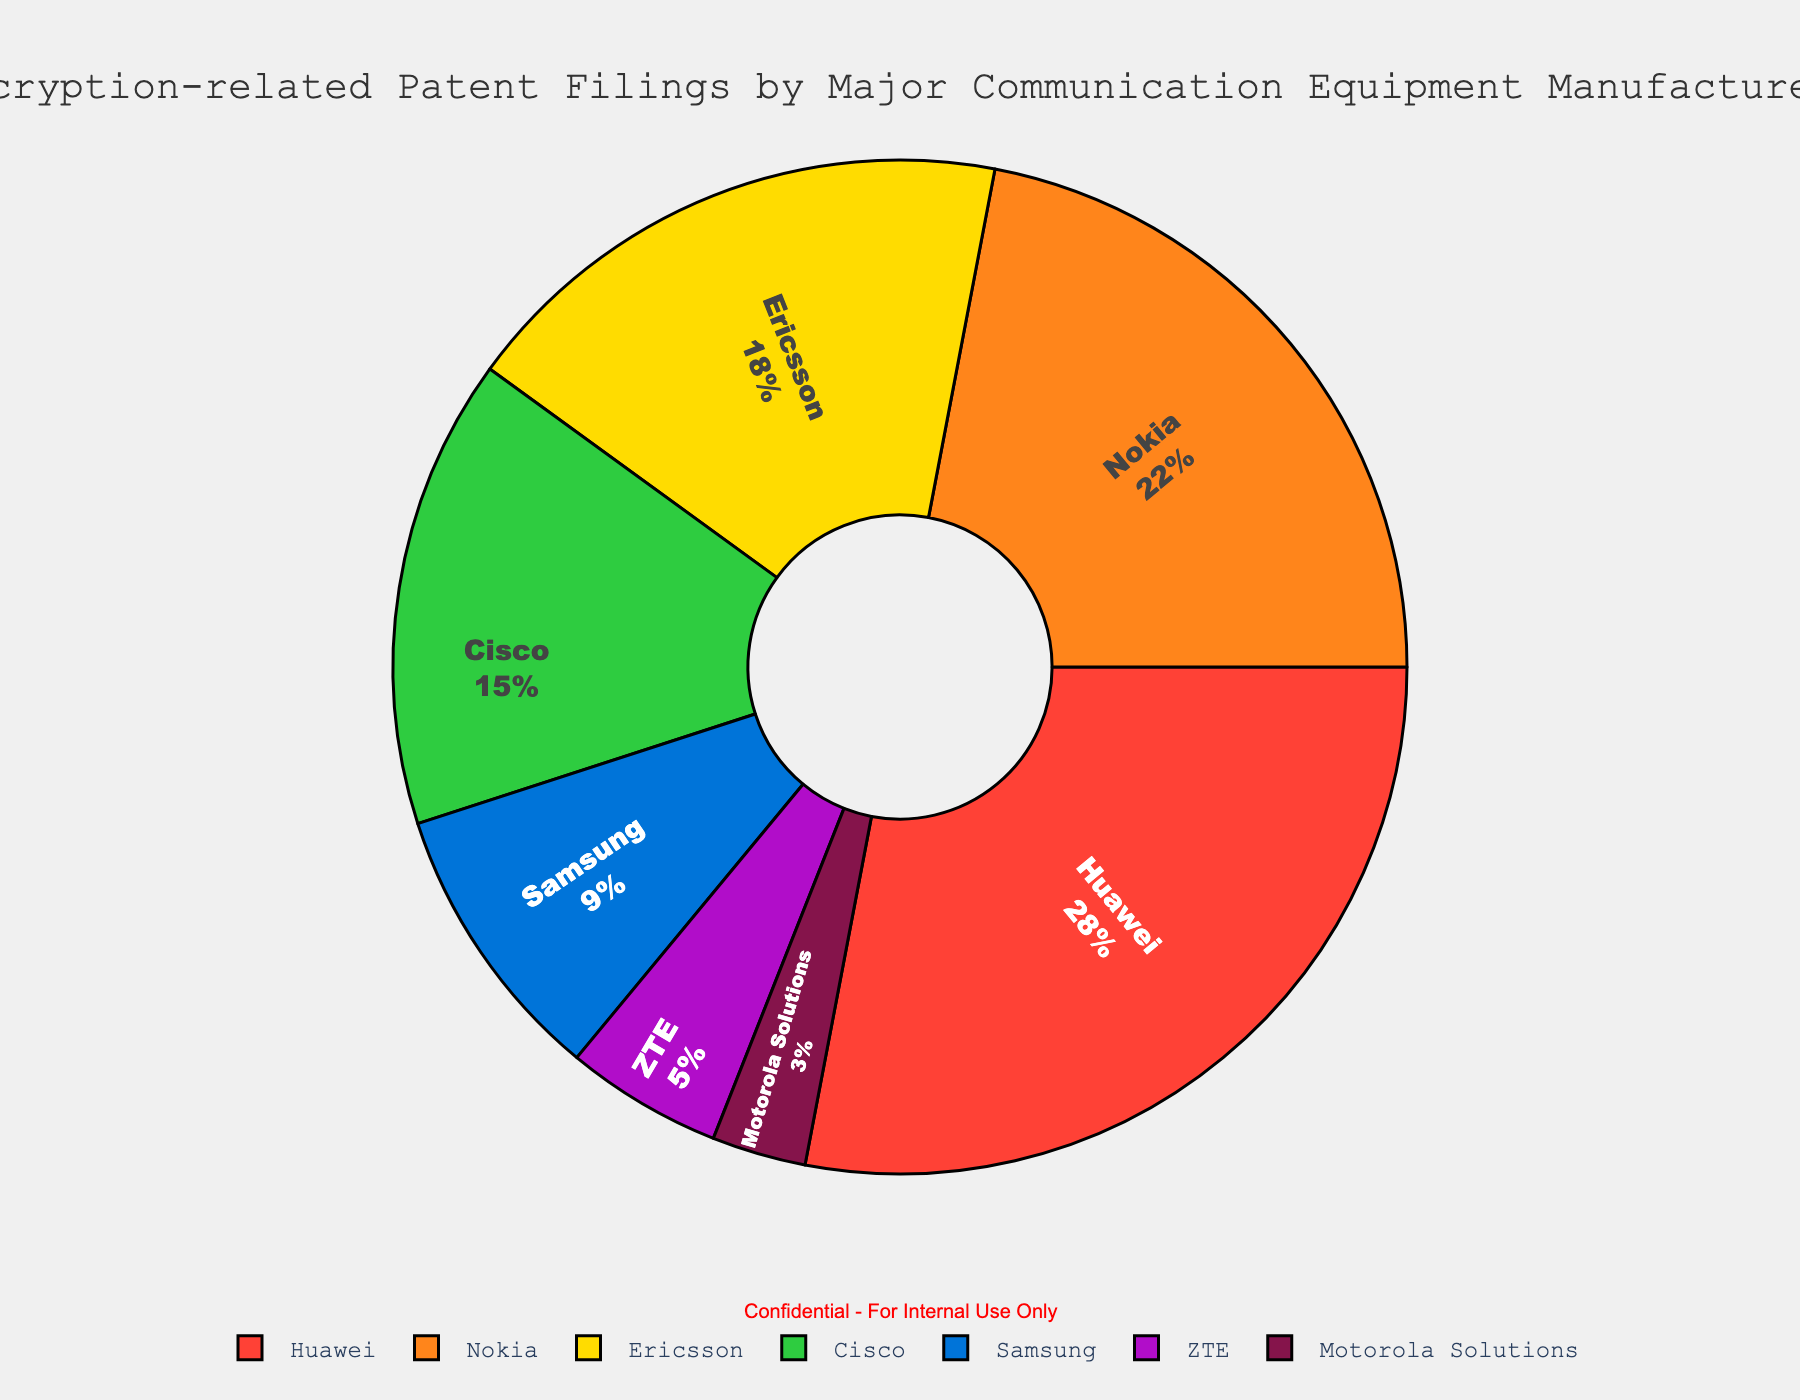What percentage of encryption-related patent filings do Huawei and Nokia have together? Add Huawei's percentage (28%) and Nokia's percentage (22%). 28 + 22 = 50
Answer: 50% What is the difference in encryption-related patent filings between Ericsson and Cisco? Subtract Cisco's percentage (15%) from Ericsson's percentage (18%). 18 - 15 = 3
Answer: 3% Which company has the second-highest percentage of encryption-related patent filings? The company with the second-highest percentage is Nokia with 22%, as Huawei has the highest at 28%.
Answer: Nokia Which companies have less than 10% of the encryption-related patent filings? From the data: Samsung (9%), ZTE (5%), Motorola Solutions (3%) are all less than 10%.
Answer: Samsung, ZTE, Motorola Solutions If you combine the encryption-related patent filings of Samsung, ZTE, and Motorola Solutions, what percentage of the total do they represent? Add the percentages of Samsung (9%), ZTE (5%), and Motorola Solutions (3%). 9 + 5 + 3 = 17
Answer: 17% Which company occupies the segment with the color green? The green segment belongs to Samsung in the pie chart.
Answer: Samsung How does the percentage of encryption-related patent filings for Cisco compare to that of ZTE? Cisco has 15%, while ZTE has 5%. 15% is greater than 5%.
Answer: Cisco's percentage is greater What is the combined percentage of encryption-related patent filings by companies other than Huawei and Nokia? Add the percentages of Ericsson (18%), Cisco (15%), Samsung (9%), ZTE (5%), and Motorola Solutions (3%). 18 + 15 + 9 + 5 + 3 = 50
Answer: 50% Which company's segment appears smallest in the pie chart? The smallest segment belongs to Motorola Solutions with 3%.
Answer: Motorola Solutions Of the companies with more than 15% of the encryption-related patent filings, which one has the lowest percentage? Ericsson has 18% which is more than 15%, and it is the lowest among those with higher than 15%.
Answer: Ericsson 